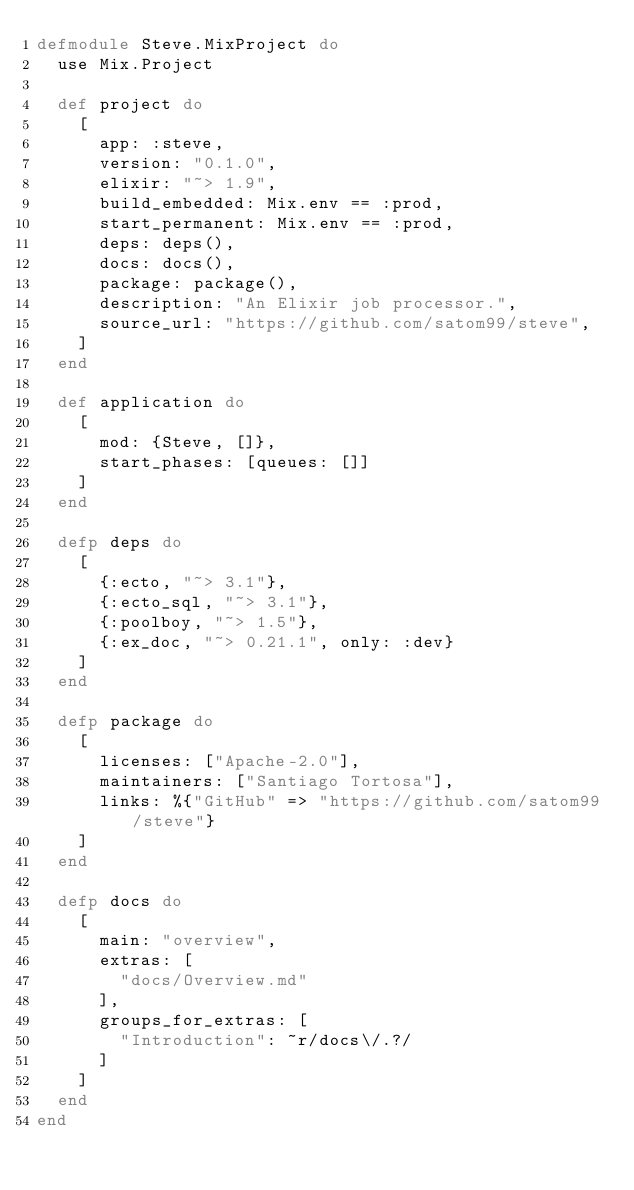Convert code to text. <code><loc_0><loc_0><loc_500><loc_500><_Elixir_>defmodule Steve.MixProject do
  use Mix.Project

  def project do
    [
      app: :steve,
      version: "0.1.0",
      elixir: "~> 1.9",
      build_embedded: Mix.env == :prod,
      start_permanent: Mix.env == :prod,
      deps: deps(),
      docs: docs(),
      package: package(),
      description: "An Elixir job processor.",
      source_url: "https://github.com/satom99/steve",
    ]
  end

  def application do
    [
      mod: {Steve, []},
      start_phases: [queues: []]
    ]
  end

  defp deps do
    [
      {:ecto, "~> 3.1"},
      {:ecto_sql, "~> 3.1"},
      {:poolboy, "~> 1.5"},
      {:ex_doc, "~> 0.21.1", only: :dev}
    ]
  end

  defp package do
    [
      licenses: ["Apache-2.0"],
      maintainers: ["Santiago Tortosa"],
      links: %{"GitHub" => "https://github.com/satom99/steve"}
    ]
  end

  defp docs do
    [
      main: "overview",
      extras: [
        "docs/Overview.md"
      ],
      groups_for_extras: [
        "Introduction": ~r/docs\/.?/
      ]
    ]
  end
end</code> 